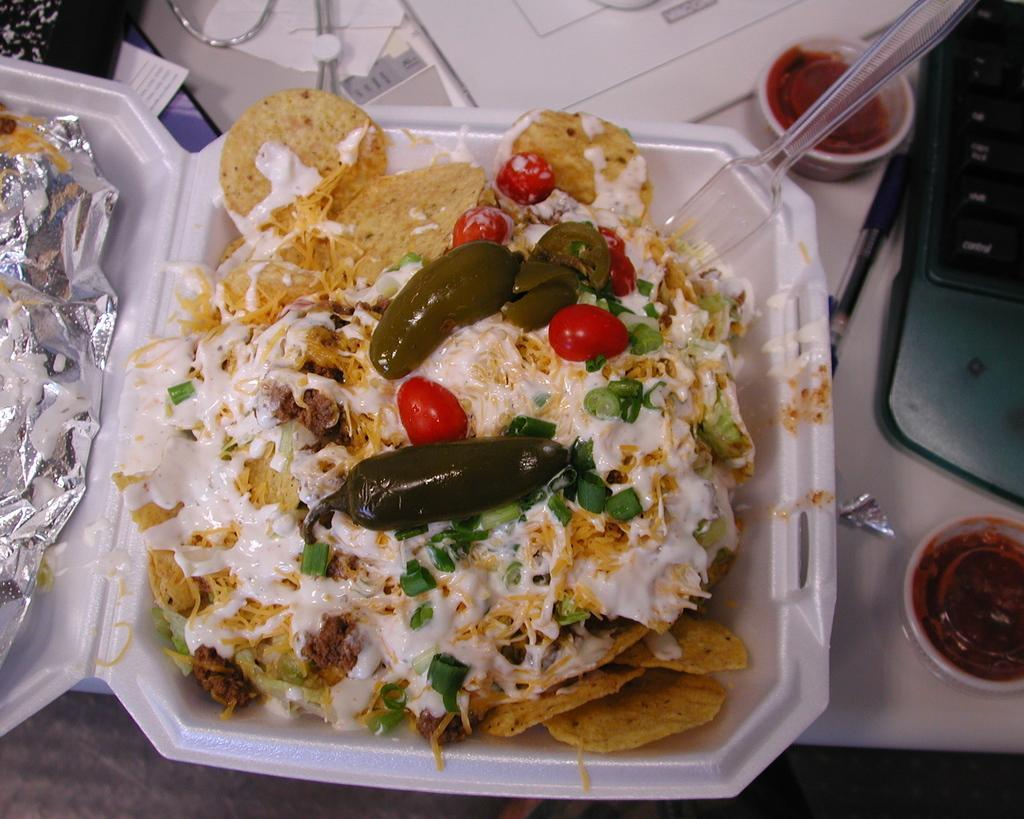What is on the table in the image? There is a box containing food on the table. What else can be seen near the laptop? There are cups beside the laptop. Can you describe the objects in the top right of the image? There is a spoon and a pen in the top right of the image. What type of horn can be seen in the image? There is no horn present in the image. Is there any dirt visible in the image? There is no dirt visible in the image. 